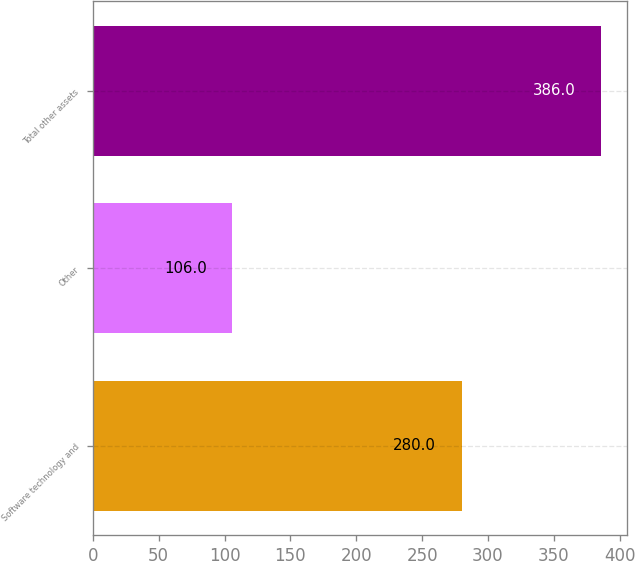Convert chart to OTSL. <chart><loc_0><loc_0><loc_500><loc_500><bar_chart><fcel>Software technology and<fcel>Other<fcel>Total other assets<nl><fcel>280<fcel>106<fcel>386<nl></chart> 